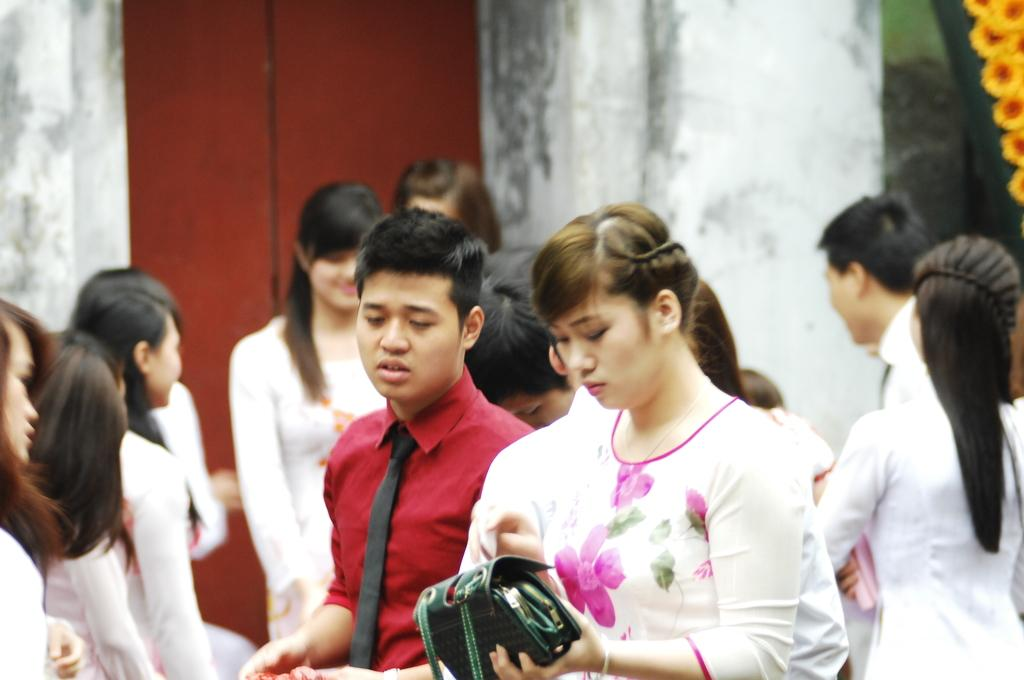Who can be seen in the image? There are people in the image. Can you describe the lady in the center of the image? The lady is standing in the center of the image, and she is holding a bag. What is visible in the background of the image? There is a wall in the background of the image. How many clocks are hanging on the wall in the image? There are no clocks visible on the wall in the image. What type of bird can be seen perched on the lady's shoulder in the image? There is no bird, specifically a robin, present on the lady's shoulder in the image. 